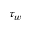Convert formula to latex. <formula><loc_0><loc_0><loc_500><loc_500>\tau _ { w }</formula> 